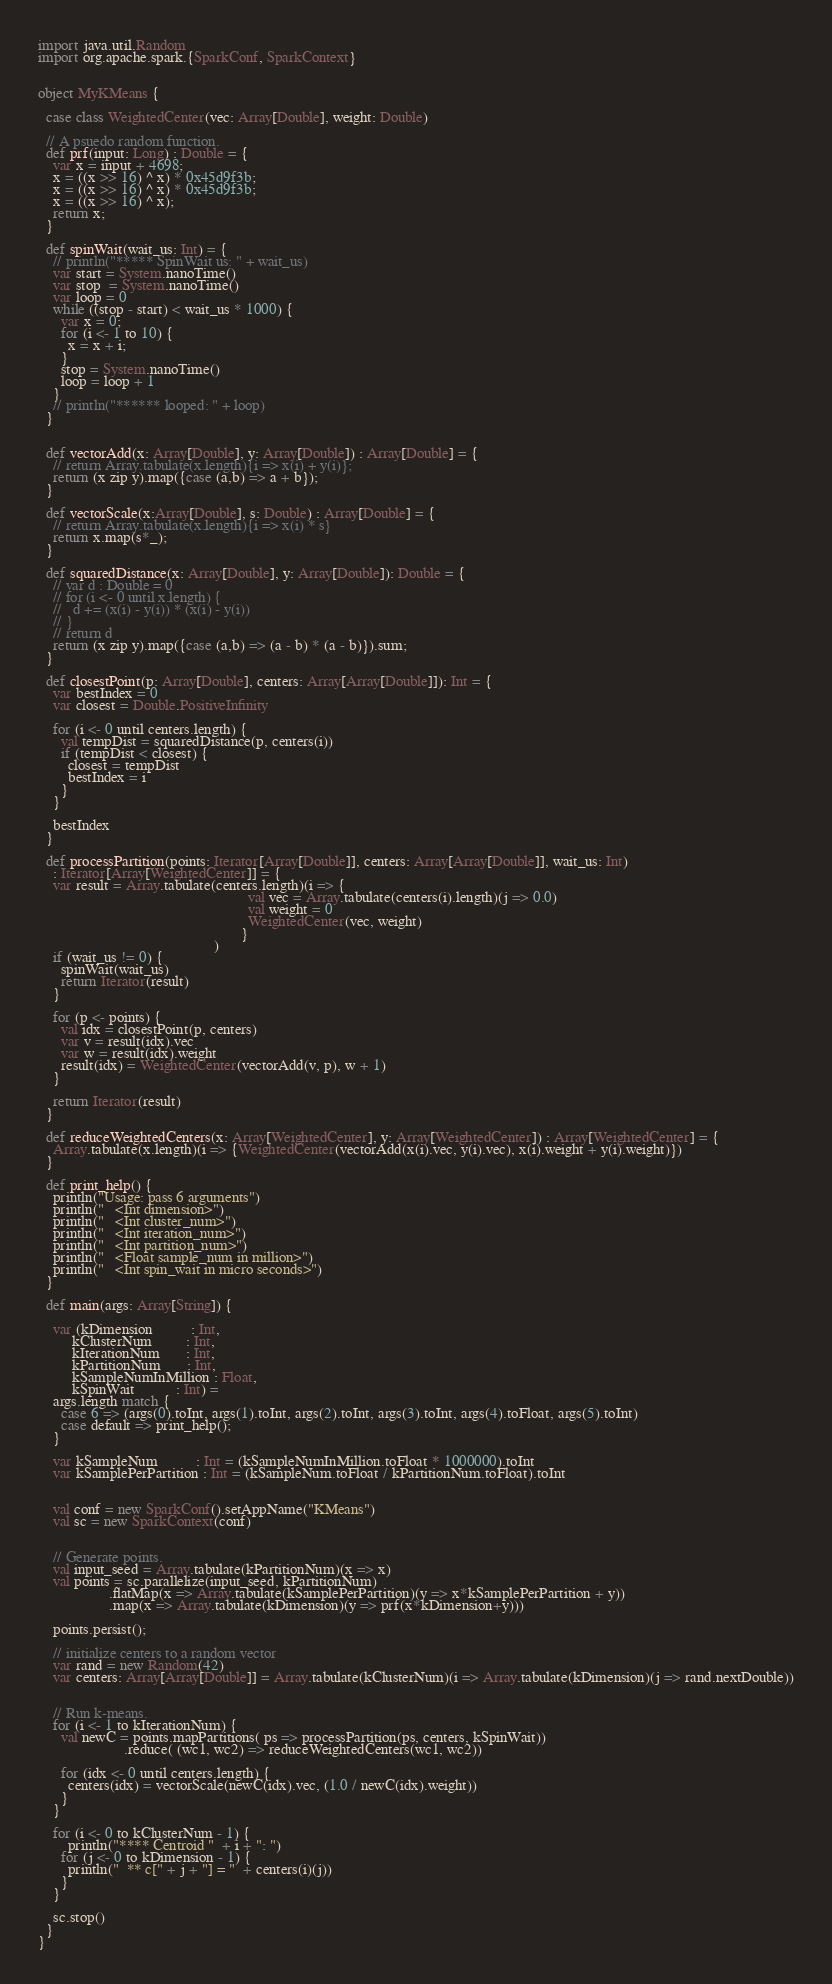<code> <loc_0><loc_0><loc_500><loc_500><_Scala_>
import java.util.Random
import org.apache.spark.{SparkConf, SparkContext}


object MyKMeans {

  case class WeightedCenter(vec: Array[Double], weight: Double)

  // A psuedo random function.
  def prf(input: Long) : Double = {
    var x = input + 4698;
    x = ((x >> 16) ^ x) * 0x45d9f3b;
    x = ((x >> 16) ^ x) * 0x45d9f3b;
    x = ((x >> 16) ^ x);
    return x;
  }

  def spinWait(wait_us: Int) = {
    // println("***** SpinWait us: " + wait_us)
    var start = System.nanoTime()
    var stop  = System.nanoTime()
    var loop = 0
    while ((stop - start) < wait_us * 1000) {
      var x = 0;
      for (i <- 1 to 10) {
        x = x + i;
      }
      stop = System.nanoTime()
      loop = loop + 1
    }
    // println("****** looped: " + loop)
  }


  def vectorAdd(x: Array[Double], y: Array[Double]) : Array[Double] = {
    // return Array.tabulate(x.length){i => x(i) + y(i)};
    return (x zip y).map({case (a,b) => a + b});
  }

  def vectorScale(x:Array[Double], s: Double) : Array[Double] = {
    // return Array.tabulate(x.length){i => x(i) * s}
    return x.map(s*_);
  }

  def squaredDistance(x: Array[Double], y: Array[Double]): Double = {
    // var d : Double = 0
    // for (i <- 0 until x.length) {
    //   d += (x(i) - y(i)) * (x(i) - y(i))
    // }
    // return d
    return (x zip y).map({case (a,b) => (a - b) * (a - b)}).sum;
  }

  def closestPoint(p: Array[Double], centers: Array[Array[Double]]): Int = {
    var bestIndex = 0
    var closest = Double.PositiveInfinity

    for (i <- 0 until centers.length) {
      val tempDist = squaredDistance(p, centers(i))
      if (tempDist < closest) {
        closest = tempDist
        bestIndex = i
      }
    }

    bestIndex
  }

  def processPartition(points: Iterator[Array[Double]], centers: Array[Array[Double]], wait_us: Int)
    : Iterator[Array[WeightedCenter]] = {
    var result = Array.tabulate(centers.length)(i => {
                                                        val vec = Array.tabulate(centers(i).length)(j => 0.0)
                                                        val weight = 0
                                                        WeightedCenter(vec, weight)
                                                      }
                                               )
    if (wait_us != 0) {
      spinWait(wait_us)
      return Iterator(result)
    }

    for (p <- points) {
      val idx = closestPoint(p, centers)
      var v = result(idx).vec
      var w = result(idx).weight
      result(idx) = WeightedCenter(vectorAdd(v, p), w + 1)
    }

    return Iterator(result)
  }

  def reduceWeightedCenters(x: Array[WeightedCenter], y: Array[WeightedCenter]) : Array[WeightedCenter] = {
    Array.tabulate(x.length)(i => {WeightedCenter(vectorAdd(x(i).vec, y(i).vec), x(i).weight + y(i).weight)})
  }

  def print_help() {
    println("Usage: pass 6 arguments")
    println("   <Int dimension>")
    println("   <Int cluster_num>")
    println("   <Int iteration_num>")
    println("   <Int partition_num>")
    println("   <Float sample_num in million>")
    println("   <Int spin_wait in micro seconds>")
  }

  def main(args: Array[String]) {

    var (kDimension          : Int,
         kClusterNum         : Int,
         kIterationNum       : Int,
         kPartitionNum       : Int,
         kSampleNumInMillion : Float,
         kSpinWait           : Int) =
    args.length match {
      case 6 => (args(0).toInt, args(1).toInt, args(2).toInt, args(3).toInt, args(4).toFloat, args(5).toInt)
      case default => print_help();
    }

    var kSampleNum          : Int = (kSampleNumInMillion.toFloat * 1000000).toInt
    var kSamplePerPartition : Int = (kSampleNum.toFloat / kPartitionNum.toFloat).toInt

    
    val conf = new SparkConf().setAppName("KMeans")
    val sc = new SparkContext(conf)


    // Generate points.
    val input_seed = Array.tabulate(kPartitionNum)(x => x)
    val points = sc.parallelize(input_seed, kPartitionNum)
                   .flatMap(x => Array.tabulate(kSamplePerPartition)(y => x*kSamplePerPartition + y))
                   .map(x => Array.tabulate(kDimension)(y => prf(x*kDimension+y)))

    points.persist();

    // initialize centers to a random vector
    var rand = new Random(42)
    var centers: Array[Array[Double]] = Array.tabulate(kClusterNum)(i => Array.tabulate(kDimension)(j => rand.nextDouble))


    // Run k-means.
    for (i <- 1 to kIterationNum) {
      val newC = points.mapPartitions( ps => processPartition(ps, centers, kSpinWait))
                       .reduce( (wc1, wc2) => reduceWeightedCenters(wc1, wc2))

      for (idx <- 0 until centers.length) {
        centers(idx) = vectorScale(newC(idx).vec, (1.0 / newC(idx).weight))
      }
    }

    for (i <- 0 to kClusterNum - 1) {
        println("**** Centroid "  + i + ": ")
      for (j <- 0 to kDimension - 1) {
        println("  ** c[" + j + "] = "  + centers(i)(j))
      }
    }

    sc.stop()
  }
}
</code> 